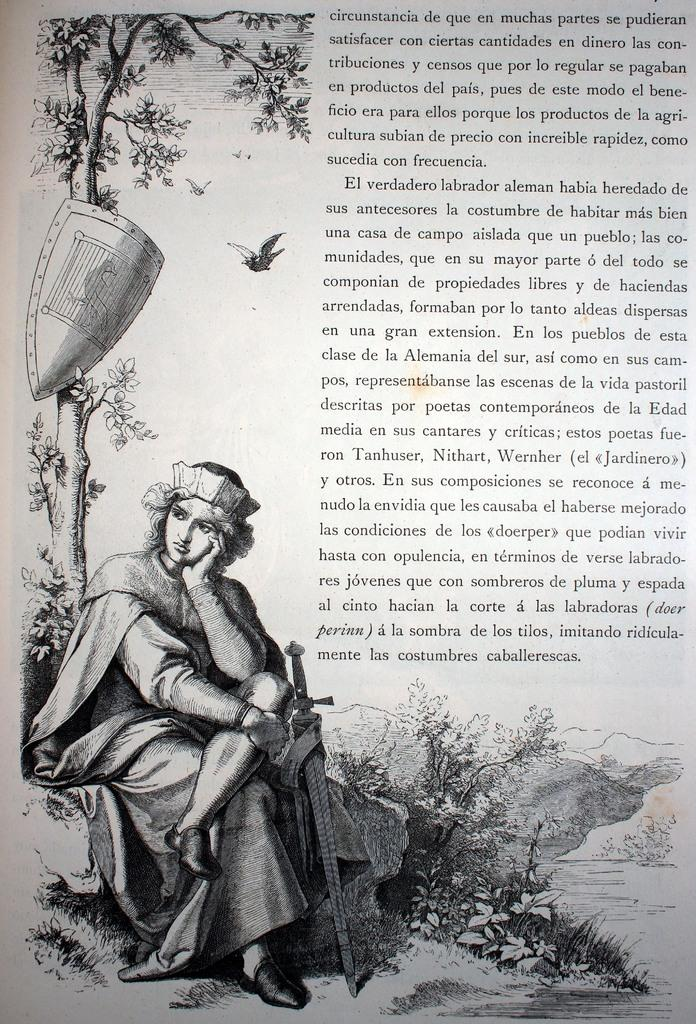What is the person in the image doing? The person is sitting on a rock in the image. Where is the person located in the image? The person is in the left corner of the image. What object is beside the person? There is a sword beside the person. What can be seen in the right corner of the image? There is something written in the right corner of the image. What type of bells can be heard ringing in the image? There are no bells present in the image, and therefore no sound can be heard. 